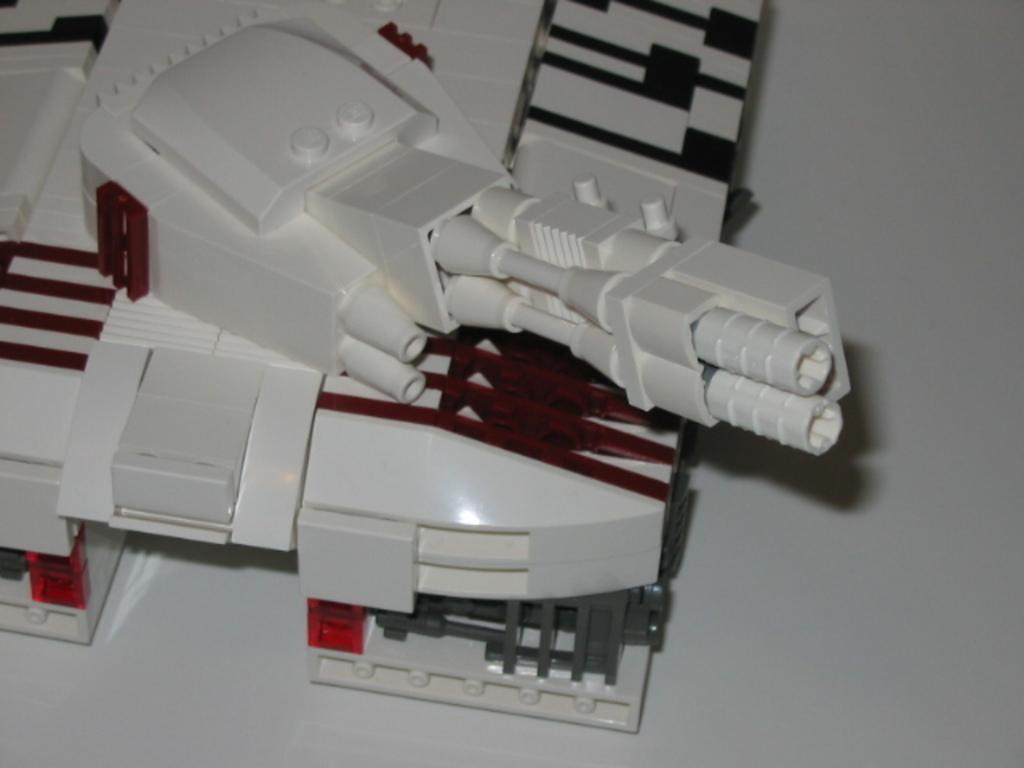What is the main object in the image? There is a toy machine in the image. Where is the toy machine located? The toy machine is on the floor. Can you describe the setting of the image? The image may have been taken in a room. What type of organization is depicted in the image? There is no organization depicted in the image; it features a toy machine on the floor. How many trees are visible in the image? There are no trees visible in the image. 